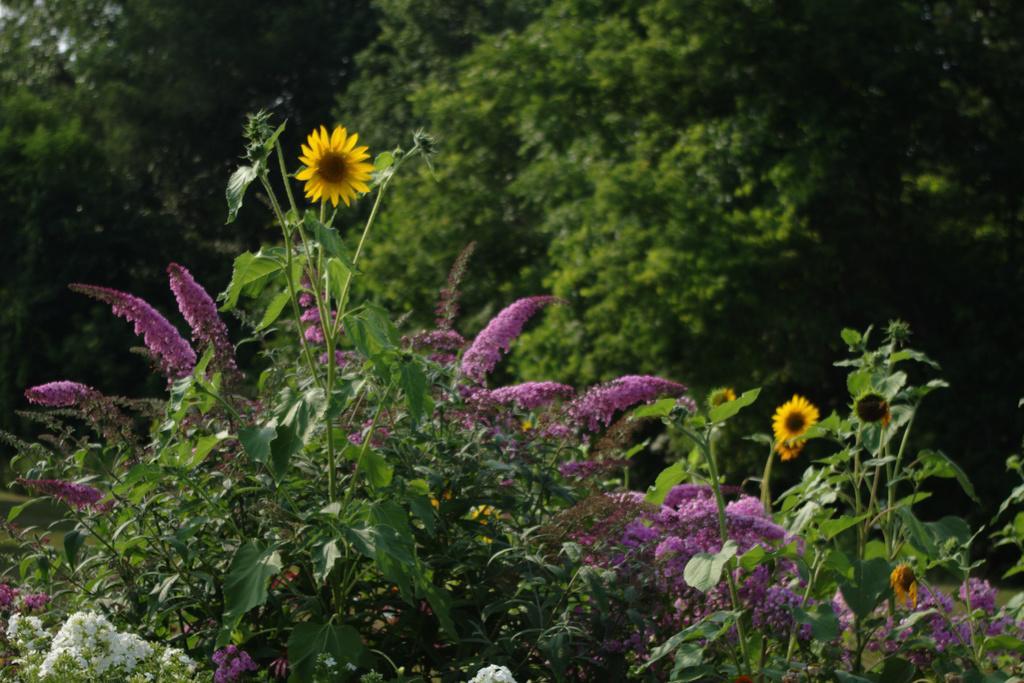In one or two sentences, can you explain what this image depicts? There are many trees and plants. There are flowers to the plants. There is a grassy land in the image. 